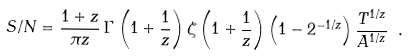<formula> <loc_0><loc_0><loc_500><loc_500>S / N = \frac { 1 + z } { \pi z } \, \Gamma \left ( 1 + { \frac { 1 } { z } } \right ) \zeta \left ( 1 + { \frac { 1 } { z } } \right ) \left ( 1 - 2 ^ { - 1 / z } \right ) \frac { T ^ { 1 / z } } { A ^ { 1 / z } } \ .</formula> 